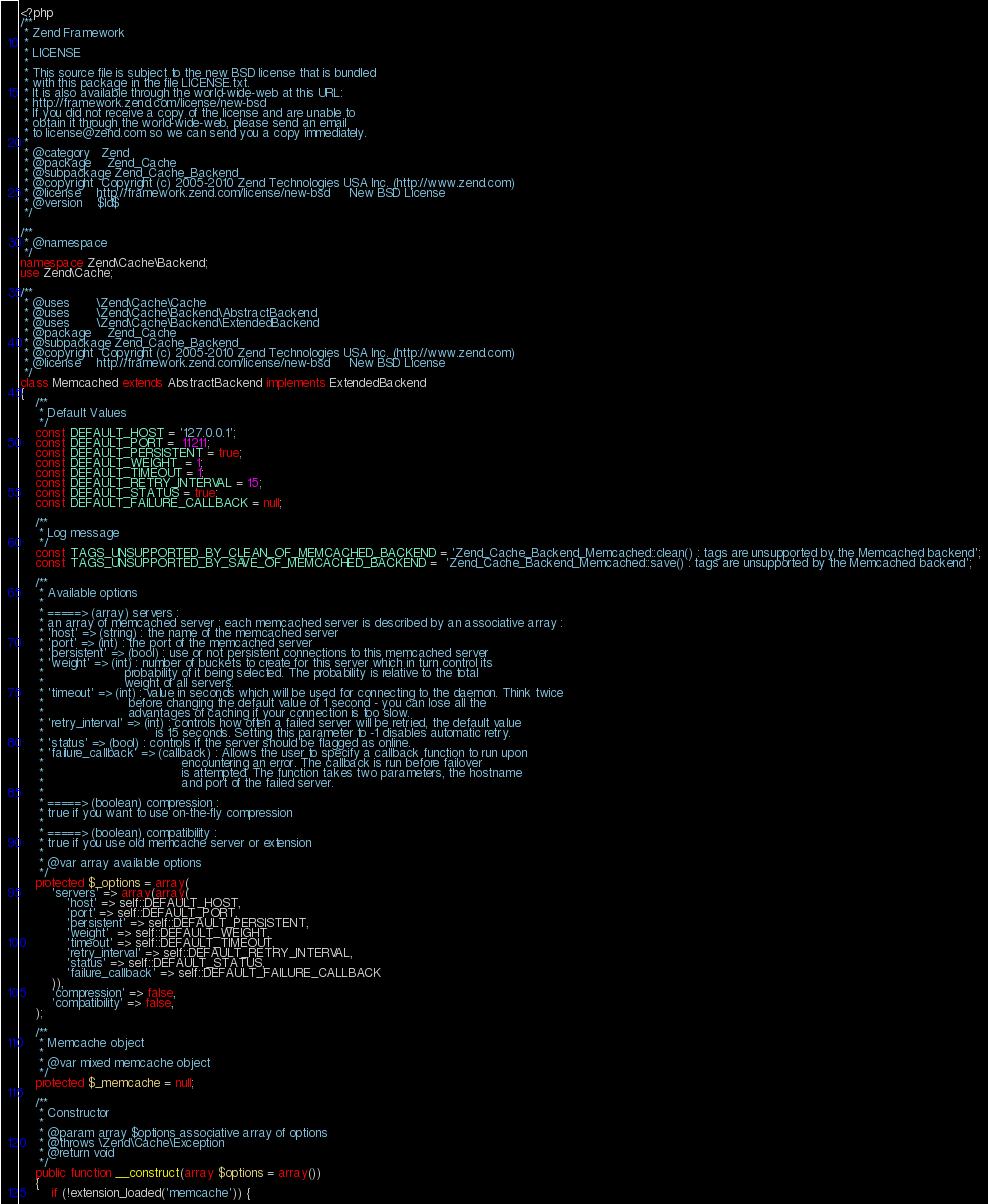<code> <loc_0><loc_0><loc_500><loc_500><_PHP_><?php
/**
 * Zend Framework
 *
 * LICENSE
 *
 * This source file is subject to the new BSD license that is bundled
 * with this package in the file LICENSE.txt.
 * It is also available through the world-wide-web at this URL:
 * http://framework.zend.com/license/new-bsd
 * If you did not receive a copy of the license and are unable to
 * obtain it through the world-wide-web, please send an email
 * to license@zend.com so we can send you a copy immediately.
 *
 * @category   Zend
 * @package    Zend_Cache
 * @subpackage Zend_Cache_Backend
 * @copyright  Copyright (c) 2005-2010 Zend Technologies USA Inc. (http://www.zend.com)
 * @license    http://framework.zend.com/license/new-bsd     New BSD License
 * @version    $Id$
 */

/**
 * @namespace
 */
namespace Zend\Cache\Backend;
use Zend\Cache;

/**
 * @uses       \Zend\Cache\Cache
 * @uses       \Zend\Cache\Backend\AbstractBackend
 * @uses       \Zend\Cache\Backend\ExtendedBackend
 * @package    Zend_Cache
 * @subpackage Zend_Cache_Backend
 * @copyright  Copyright (c) 2005-2010 Zend Technologies USA Inc. (http://www.zend.com)
 * @license    http://framework.zend.com/license/new-bsd     New BSD License
 */
class Memcached extends AbstractBackend implements ExtendedBackend
{
    /**
     * Default Values
     */
    const DEFAULT_HOST = '127.0.0.1';
    const DEFAULT_PORT =  11211;
    const DEFAULT_PERSISTENT = true;
    const DEFAULT_WEIGHT  = 1;
    const DEFAULT_TIMEOUT = 1;
    const DEFAULT_RETRY_INTERVAL = 15;
    const DEFAULT_STATUS = true;
    const DEFAULT_FAILURE_CALLBACK = null;

    /**
     * Log message
     */
    const TAGS_UNSUPPORTED_BY_CLEAN_OF_MEMCACHED_BACKEND = 'Zend_Cache_Backend_Memcached::clean() : tags are unsupported by the Memcached backend';
    const TAGS_UNSUPPORTED_BY_SAVE_OF_MEMCACHED_BACKEND =  'Zend_Cache_Backend_Memcached::save() : tags are unsupported by the Memcached backend';

    /**
     * Available options
     *
     * =====> (array) servers :
     * an array of memcached server ; each memcached server is described by an associative array :
     * 'host' => (string) : the name of the memcached server
     * 'port' => (int) : the port of the memcached server
     * 'persistent' => (bool) : use or not persistent connections to this memcached server
     * 'weight' => (int) : number of buckets to create for this server which in turn control its
     *                     probability of it being selected. The probability is relative to the total
     *                     weight of all servers.
     * 'timeout' => (int) : value in seconds which will be used for connecting to the daemon. Think twice
     *                      before changing the default value of 1 second - you can lose all the
     *                      advantages of caching if your connection is too slow.
     * 'retry_interval' => (int) : controls how often a failed server will be retried, the default value
     *                             is 15 seconds. Setting this parameter to -1 disables automatic retry.
     * 'status' => (bool) : controls if the server should be flagged as online.
     * 'failure_callback' => (callback) : Allows the user to specify a callback function to run upon
     *                                    encountering an error. The callback is run before failover
     *                                    is attempted. The function takes two parameters, the hostname
     *                                    and port of the failed server.
     *
     * =====> (boolean) compression :
     * true if you want to use on-the-fly compression
     *
     * =====> (boolean) compatibility :
     * true if you use old memcache server or extension
     *
     * @var array available options
     */
    protected $_options = array(
        'servers' => array(array(
            'host' => self::DEFAULT_HOST,
            'port' => self::DEFAULT_PORT,
            'persistent' => self::DEFAULT_PERSISTENT,
            'weight'  => self::DEFAULT_WEIGHT,
            'timeout' => self::DEFAULT_TIMEOUT,
            'retry_interval' => self::DEFAULT_RETRY_INTERVAL,
            'status' => self::DEFAULT_STATUS,
            'failure_callback' => self::DEFAULT_FAILURE_CALLBACK
        )),
        'compression' => false,
        'compatibility' => false,
    );

    /**
     * Memcache object
     *
     * @var mixed memcache object
     */
    protected $_memcache = null;

    /**
     * Constructor
     *
     * @param array $options associative array of options
     * @throws \Zend\Cache\Exception
     * @return void
     */
    public function __construct(array $options = array())
    {
        if (!extension_loaded('memcache')) {</code> 